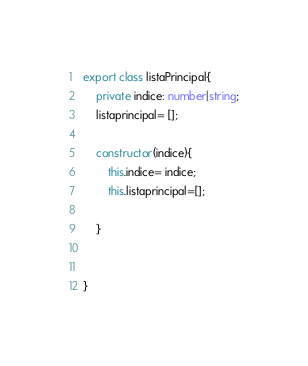<code> <loc_0><loc_0><loc_500><loc_500><_TypeScript_>export class listaPrincipal{
    private indice: number|string;
    listaprincipal= [];
     
    constructor(indice){
        this.indice= indice;
        this.listaprincipal=[];
        
    }
    

}</code> 